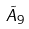Convert formula to latex. <formula><loc_0><loc_0><loc_500><loc_500>\tilde { A } _ { 9 }</formula> 